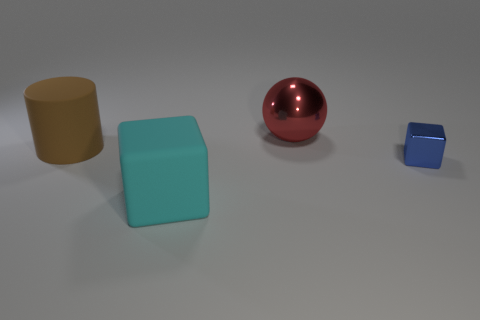Are there any other things that have the same size as the blue shiny thing?
Make the answer very short. No. What number of other things are there of the same shape as the blue object?
Offer a very short reply. 1. How big is the cube behind the thing that is in front of the metal thing in front of the red sphere?
Keep it short and to the point. Small. What number of blue things are either large metallic objects or tiny cubes?
Your answer should be very brief. 1. There is a blue object right of the matte thing in front of the brown matte thing; what shape is it?
Make the answer very short. Cube. There is a object that is to the left of the cyan block; is its size the same as the block left of the tiny block?
Ensure brevity in your answer.  Yes. Is there a brown thing that has the same material as the small block?
Ensure brevity in your answer.  No. There is a cube that is on the left side of the big object behind the brown object; are there any red balls behind it?
Your answer should be compact. Yes. There is a brown matte thing; are there any objects on the right side of it?
Offer a terse response. Yes. There is a large rubber thing in front of the tiny block; what number of rubber objects are behind it?
Make the answer very short. 1. 